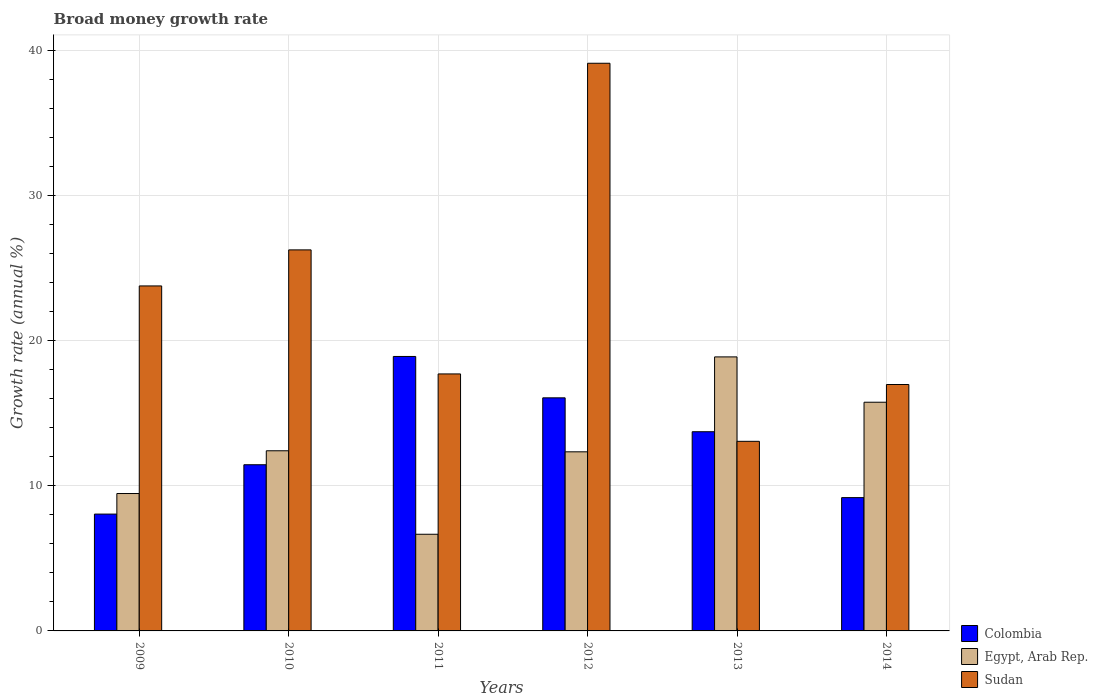How many different coloured bars are there?
Your answer should be very brief. 3. Are the number of bars per tick equal to the number of legend labels?
Make the answer very short. Yes. How many bars are there on the 5th tick from the right?
Ensure brevity in your answer.  3. In how many cases, is the number of bars for a given year not equal to the number of legend labels?
Ensure brevity in your answer.  0. What is the growth rate in Egypt, Arab Rep. in 2010?
Provide a short and direct response. 12.42. Across all years, what is the maximum growth rate in Colombia?
Your answer should be compact. 18.92. Across all years, what is the minimum growth rate in Sudan?
Give a very brief answer. 13.07. What is the total growth rate in Colombia in the graph?
Your answer should be very brief. 77.43. What is the difference between the growth rate in Sudan in 2011 and that in 2012?
Provide a short and direct response. -21.42. What is the difference between the growth rate in Colombia in 2010 and the growth rate in Egypt, Arab Rep. in 2009?
Ensure brevity in your answer.  1.98. What is the average growth rate in Sudan per year?
Keep it short and to the point. 22.83. In the year 2011, what is the difference between the growth rate in Sudan and growth rate in Colombia?
Ensure brevity in your answer.  -1.2. What is the ratio of the growth rate in Sudan in 2009 to that in 2011?
Your answer should be very brief. 1.34. Is the growth rate in Egypt, Arab Rep. in 2010 less than that in 2012?
Keep it short and to the point. No. Is the difference between the growth rate in Sudan in 2010 and 2012 greater than the difference between the growth rate in Colombia in 2010 and 2012?
Keep it short and to the point. No. What is the difference between the highest and the second highest growth rate in Colombia?
Your answer should be compact. 2.85. What is the difference between the highest and the lowest growth rate in Sudan?
Offer a terse response. 26.07. Is the sum of the growth rate in Sudan in 2011 and 2013 greater than the maximum growth rate in Egypt, Arab Rep. across all years?
Provide a short and direct response. Yes. What does the 2nd bar from the left in 2011 represents?
Provide a short and direct response. Egypt, Arab Rep. What does the 2nd bar from the right in 2010 represents?
Make the answer very short. Egypt, Arab Rep. Is it the case that in every year, the sum of the growth rate in Egypt, Arab Rep. and growth rate in Sudan is greater than the growth rate in Colombia?
Offer a very short reply. Yes. What is the difference between two consecutive major ticks on the Y-axis?
Provide a succinct answer. 10. Does the graph contain grids?
Offer a terse response. Yes. How many legend labels are there?
Make the answer very short. 3. What is the title of the graph?
Give a very brief answer. Broad money growth rate. What is the label or title of the X-axis?
Your answer should be compact. Years. What is the label or title of the Y-axis?
Ensure brevity in your answer.  Growth rate (annual %). What is the Growth rate (annual %) of Colombia in 2009?
Your answer should be very brief. 8.06. What is the Growth rate (annual %) of Egypt, Arab Rep. in 2009?
Offer a very short reply. 9.47. What is the Growth rate (annual %) in Sudan in 2009?
Provide a short and direct response. 23.79. What is the Growth rate (annual %) in Colombia in 2010?
Provide a short and direct response. 11.46. What is the Growth rate (annual %) of Egypt, Arab Rep. in 2010?
Make the answer very short. 12.42. What is the Growth rate (annual %) in Sudan in 2010?
Your response must be concise. 26.27. What is the Growth rate (annual %) of Colombia in 2011?
Your answer should be compact. 18.92. What is the Growth rate (annual %) in Egypt, Arab Rep. in 2011?
Provide a succinct answer. 6.66. What is the Growth rate (annual %) of Sudan in 2011?
Keep it short and to the point. 17.72. What is the Growth rate (annual %) of Colombia in 2012?
Provide a short and direct response. 16.07. What is the Growth rate (annual %) of Egypt, Arab Rep. in 2012?
Keep it short and to the point. 12.35. What is the Growth rate (annual %) of Sudan in 2012?
Provide a succinct answer. 39.14. What is the Growth rate (annual %) of Colombia in 2013?
Your answer should be compact. 13.73. What is the Growth rate (annual %) in Egypt, Arab Rep. in 2013?
Ensure brevity in your answer.  18.89. What is the Growth rate (annual %) of Sudan in 2013?
Ensure brevity in your answer.  13.07. What is the Growth rate (annual %) in Colombia in 2014?
Your answer should be very brief. 9.19. What is the Growth rate (annual %) of Egypt, Arab Rep. in 2014?
Your answer should be very brief. 15.77. What is the Growth rate (annual %) of Sudan in 2014?
Provide a short and direct response. 16.99. Across all years, what is the maximum Growth rate (annual %) of Colombia?
Your answer should be compact. 18.92. Across all years, what is the maximum Growth rate (annual %) of Egypt, Arab Rep.?
Make the answer very short. 18.89. Across all years, what is the maximum Growth rate (annual %) of Sudan?
Provide a succinct answer. 39.14. Across all years, what is the minimum Growth rate (annual %) in Colombia?
Your answer should be compact. 8.06. Across all years, what is the minimum Growth rate (annual %) of Egypt, Arab Rep.?
Provide a short and direct response. 6.66. Across all years, what is the minimum Growth rate (annual %) of Sudan?
Offer a terse response. 13.07. What is the total Growth rate (annual %) of Colombia in the graph?
Ensure brevity in your answer.  77.43. What is the total Growth rate (annual %) of Egypt, Arab Rep. in the graph?
Offer a terse response. 75.57. What is the total Growth rate (annual %) in Sudan in the graph?
Your response must be concise. 136.98. What is the difference between the Growth rate (annual %) of Colombia in 2009 and that in 2010?
Your answer should be very brief. -3.4. What is the difference between the Growth rate (annual %) in Egypt, Arab Rep. in 2009 and that in 2010?
Offer a terse response. -2.95. What is the difference between the Growth rate (annual %) of Sudan in 2009 and that in 2010?
Make the answer very short. -2.49. What is the difference between the Growth rate (annual %) in Colombia in 2009 and that in 2011?
Offer a very short reply. -10.87. What is the difference between the Growth rate (annual %) in Egypt, Arab Rep. in 2009 and that in 2011?
Provide a succinct answer. 2.81. What is the difference between the Growth rate (annual %) of Sudan in 2009 and that in 2011?
Offer a terse response. 6.07. What is the difference between the Growth rate (annual %) of Colombia in 2009 and that in 2012?
Offer a very short reply. -8.02. What is the difference between the Growth rate (annual %) in Egypt, Arab Rep. in 2009 and that in 2012?
Keep it short and to the point. -2.87. What is the difference between the Growth rate (annual %) in Sudan in 2009 and that in 2012?
Give a very brief answer. -15.35. What is the difference between the Growth rate (annual %) of Colombia in 2009 and that in 2013?
Give a very brief answer. -5.68. What is the difference between the Growth rate (annual %) in Egypt, Arab Rep. in 2009 and that in 2013?
Your answer should be very brief. -9.42. What is the difference between the Growth rate (annual %) in Sudan in 2009 and that in 2013?
Provide a short and direct response. 10.71. What is the difference between the Growth rate (annual %) in Colombia in 2009 and that in 2014?
Your answer should be compact. -1.14. What is the difference between the Growth rate (annual %) in Egypt, Arab Rep. in 2009 and that in 2014?
Your answer should be very brief. -6.29. What is the difference between the Growth rate (annual %) in Sudan in 2009 and that in 2014?
Provide a short and direct response. 6.8. What is the difference between the Growth rate (annual %) of Colombia in 2010 and that in 2011?
Your answer should be very brief. -7.47. What is the difference between the Growth rate (annual %) in Egypt, Arab Rep. in 2010 and that in 2011?
Give a very brief answer. 5.76. What is the difference between the Growth rate (annual %) in Sudan in 2010 and that in 2011?
Provide a short and direct response. 8.55. What is the difference between the Growth rate (annual %) in Colombia in 2010 and that in 2012?
Give a very brief answer. -4.61. What is the difference between the Growth rate (annual %) in Egypt, Arab Rep. in 2010 and that in 2012?
Provide a short and direct response. 0.07. What is the difference between the Growth rate (annual %) in Sudan in 2010 and that in 2012?
Give a very brief answer. -12.87. What is the difference between the Growth rate (annual %) of Colombia in 2010 and that in 2013?
Offer a terse response. -2.28. What is the difference between the Growth rate (annual %) of Egypt, Arab Rep. in 2010 and that in 2013?
Offer a terse response. -6.47. What is the difference between the Growth rate (annual %) in Sudan in 2010 and that in 2013?
Offer a terse response. 13.2. What is the difference between the Growth rate (annual %) in Colombia in 2010 and that in 2014?
Your answer should be very brief. 2.27. What is the difference between the Growth rate (annual %) of Egypt, Arab Rep. in 2010 and that in 2014?
Make the answer very short. -3.35. What is the difference between the Growth rate (annual %) in Sudan in 2010 and that in 2014?
Offer a very short reply. 9.28. What is the difference between the Growth rate (annual %) in Colombia in 2011 and that in 2012?
Keep it short and to the point. 2.85. What is the difference between the Growth rate (annual %) in Egypt, Arab Rep. in 2011 and that in 2012?
Your answer should be compact. -5.68. What is the difference between the Growth rate (annual %) in Sudan in 2011 and that in 2012?
Provide a short and direct response. -21.42. What is the difference between the Growth rate (annual %) of Colombia in 2011 and that in 2013?
Provide a succinct answer. 5.19. What is the difference between the Growth rate (annual %) in Egypt, Arab Rep. in 2011 and that in 2013?
Provide a succinct answer. -12.23. What is the difference between the Growth rate (annual %) in Sudan in 2011 and that in 2013?
Keep it short and to the point. 4.65. What is the difference between the Growth rate (annual %) in Colombia in 2011 and that in 2014?
Offer a terse response. 9.73. What is the difference between the Growth rate (annual %) in Egypt, Arab Rep. in 2011 and that in 2014?
Keep it short and to the point. -9.1. What is the difference between the Growth rate (annual %) of Sudan in 2011 and that in 2014?
Provide a succinct answer. 0.73. What is the difference between the Growth rate (annual %) of Colombia in 2012 and that in 2013?
Ensure brevity in your answer.  2.34. What is the difference between the Growth rate (annual %) of Egypt, Arab Rep. in 2012 and that in 2013?
Your response must be concise. -6.55. What is the difference between the Growth rate (annual %) of Sudan in 2012 and that in 2013?
Ensure brevity in your answer.  26.07. What is the difference between the Growth rate (annual %) of Colombia in 2012 and that in 2014?
Offer a terse response. 6.88. What is the difference between the Growth rate (annual %) in Egypt, Arab Rep. in 2012 and that in 2014?
Ensure brevity in your answer.  -3.42. What is the difference between the Growth rate (annual %) in Sudan in 2012 and that in 2014?
Your answer should be compact. 22.15. What is the difference between the Growth rate (annual %) of Colombia in 2013 and that in 2014?
Give a very brief answer. 4.54. What is the difference between the Growth rate (annual %) in Egypt, Arab Rep. in 2013 and that in 2014?
Offer a very short reply. 3.13. What is the difference between the Growth rate (annual %) of Sudan in 2013 and that in 2014?
Provide a short and direct response. -3.92. What is the difference between the Growth rate (annual %) of Colombia in 2009 and the Growth rate (annual %) of Egypt, Arab Rep. in 2010?
Keep it short and to the point. -4.36. What is the difference between the Growth rate (annual %) of Colombia in 2009 and the Growth rate (annual %) of Sudan in 2010?
Give a very brief answer. -18.22. What is the difference between the Growth rate (annual %) in Egypt, Arab Rep. in 2009 and the Growth rate (annual %) in Sudan in 2010?
Provide a succinct answer. -16.8. What is the difference between the Growth rate (annual %) in Colombia in 2009 and the Growth rate (annual %) in Egypt, Arab Rep. in 2011?
Your answer should be compact. 1.39. What is the difference between the Growth rate (annual %) in Colombia in 2009 and the Growth rate (annual %) in Sudan in 2011?
Your answer should be very brief. -9.66. What is the difference between the Growth rate (annual %) in Egypt, Arab Rep. in 2009 and the Growth rate (annual %) in Sudan in 2011?
Your response must be concise. -8.25. What is the difference between the Growth rate (annual %) in Colombia in 2009 and the Growth rate (annual %) in Egypt, Arab Rep. in 2012?
Ensure brevity in your answer.  -4.29. What is the difference between the Growth rate (annual %) in Colombia in 2009 and the Growth rate (annual %) in Sudan in 2012?
Your answer should be very brief. -31.08. What is the difference between the Growth rate (annual %) in Egypt, Arab Rep. in 2009 and the Growth rate (annual %) in Sudan in 2012?
Your answer should be very brief. -29.67. What is the difference between the Growth rate (annual %) in Colombia in 2009 and the Growth rate (annual %) in Egypt, Arab Rep. in 2013?
Offer a terse response. -10.84. What is the difference between the Growth rate (annual %) of Colombia in 2009 and the Growth rate (annual %) of Sudan in 2013?
Offer a terse response. -5.02. What is the difference between the Growth rate (annual %) of Egypt, Arab Rep. in 2009 and the Growth rate (annual %) of Sudan in 2013?
Ensure brevity in your answer.  -3.6. What is the difference between the Growth rate (annual %) of Colombia in 2009 and the Growth rate (annual %) of Egypt, Arab Rep. in 2014?
Provide a short and direct response. -7.71. What is the difference between the Growth rate (annual %) of Colombia in 2009 and the Growth rate (annual %) of Sudan in 2014?
Make the answer very short. -8.93. What is the difference between the Growth rate (annual %) in Egypt, Arab Rep. in 2009 and the Growth rate (annual %) in Sudan in 2014?
Offer a very short reply. -7.52. What is the difference between the Growth rate (annual %) of Colombia in 2010 and the Growth rate (annual %) of Egypt, Arab Rep. in 2011?
Make the answer very short. 4.79. What is the difference between the Growth rate (annual %) of Colombia in 2010 and the Growth rate (annual %) of Sudan in 2011?
Your answer should be very brief. -6.26. What is the difference between the Growth rate (annual %) in Egypt, Arab Rep. in 2010 and the Growth rate (annual %) in Sudan in 2011?
Your response must be concise. -5.3. What is the difference between the Growth rate (annual %) in Colombia in 2010 and the Growth rate (annual %) in Egypt, Arab Rep. in 2012?
Your response must be concise. -0.89. What is the difference between the Growth rate (annual %) of Colombia in 2010 and the Growth rate (annual %) of Sudan in 2012?
Your answer should be compact. -27.68. What is the difference between the Growth rate (annual %) of Egypt, Arab Rep. in 2010 and the Growth rate (annual %) of Sudan in 2012?
Your answer should be compact. -26.72. What is the difference between the Growth rate (annual %) in Colombia in 2010 and the Growth rate (annual %) in Egypt, Arab Rep. in 2013?
Offer a terse response. -7.44. What is the difference between the Growth rate (annual %) in Colombia in 2010 and the Growth rate (annual %) in Sudan in 2013?
Make the answer very short. -1.62. What is the difference between the Growth rate (annual %) of Egypt, Arab Rep. in 2010 and the Growth rate (annual %) of Sudan in 2013?
Your answer should be compact. -0.65. What is the difference between the Growth rate (annual %) of Colombia in 2010 and the Growth rate (annual %) of Egypt, Arab Rep. in 2014?
Make the answer very short. -4.31. What is the difference between the Growth rate (annual %) in Colombia in 2010 and the Growth rate (annual %) in Sudan in 2014?
Your response must be concise. -5.53. What is the difference between the Growth rate (annual %) in Egypt, Arab Rep. in 2010 and the Growth rate (annual %) in Sudan in 2014?
Provide a succinct answer. -4.57. What is the difference between the Growth rate (annual %) of Colombia in 2011 and the Growth rate (annual %) of Egypt, Arab Rep. in 2012?
Your answer should be compact. 6.57. What is the difference between the Growth rate (annual %) in Colombia in 2011 and the Growth rate (annual %) in Sudan in 2012?
Give a very brief answer. -20.22. What is the difference between the Growth rate (annual %) in Egypt, Arab Rep. in 2011 and the Growth rate (annual %) in Sudan in 2012?
Make the answer very short. -32.48. What is the difference between the Growth rate (annual %) of Colombia in 2011 and the Growth rate (annual %) of Egypt, Arab Rep. in 2013?
Make the answer very short. 0.03. What is the difference between the Growth rate (annual %) in Colombia in 2011 and the Growth rate (annual %) in Sudan in 2013?
Ensure brevity in your answer.  5.85. What is the difference between the Growth rate (annual %) of Egypt, Arab Rep. in 2011 and the Growth rate (annual %) of Sudan in 2013?
Keep it short and to the point. -6.41. What is the difference between the Growth rate (annual %) of Colombia in 2011 and the Growth rate (annual %) of Egypt, Arab Rep. in 2014?
Your answer should be compact. 3.16. What is the difference between the Growth rate (annual %) of Colombia in 2011 and the Growth rate (annual %) of Sudan in 2014?
Your answer should be very brief. 1.93. What is the difference between the Growth rate (annual %) of Egypt, Arab Rep. in 2011 and the Growth rate (annual %) of Sudan in 2014?
Your answer should be compact. -10.33. What is the difference between the Growth rate (annual %) in Colombia in 2012 and the Growth rate (annual %) in Egypt, Arab Rep. in 2013?
Your answer should be compact. -2.82. What is the difference between the Growth rate (annual %) in Colombia in 2012 and the Growth rate (annual %) in Sudan in 2013?
Give a very brief answer. 3. What is the difference between the Growth rate (annual %) in Egypt, Arab Rep. in 2012 and the Growth rate (annual %) in Sudan in 2013?
Ensure brevity in your answer.  -0.72. What is the difference between the Growth rate (annual %) of Colombia in 2012 and the Growth rate (annual %) of Egypt, Arab Rep. in 2014?
Provide a succinct answer. 0.3. What is the difference between the Growth rate (annual %) of Colombia in 2012 and the Growth rate (annual %) of Sudan in 2014?
Ensure brevity in your answer.  -0.92. What is the difference between the Growth rate (annual %) of Egypt, Arab Rep. in 2012 and the Growth rate (annual %) of Sudan in 2014?
Offer a very short reply. -4.64. What is the difference between the Growth rate (annual %) of Colombia in 2013 and the Growth rate (annual %) of Egypt, Arab Rep. in 2014?
Offer a terse response. -2.03. What is the difference between the Growth rate (annual %) of Colombia in 2013 and the Growth rate (annual %) of Sudan in 2014?
Ensure brevity in your answer.  -3.26. What is the difference between the Growth rate (annual %) in Egypt, Arab Rep. in 2013 and the Growth rate (annual %) in Sudan in 2014?
Your answer should be compact. 1.9. What is the average Growth rate (annual %) in Colombia per year?
Make the answer very short. 12.91. What is the average Growth rate (annual %) in Egypt, Arab Rep. per year?
Give a very brief answer. 12.6. What is the average Growth rate (annual %) in Sudan per year?
Provide a succinct answer. 22.83. In the year 2009, what is the difference between the Growth rate (annual %) in Colombia and Growth rate (annual %) in Egypt, Arab Rep.?
Offer a very short reply. -1.42. In the year 2009, what is the difference between the Growth rate (annual %) of Colombia and Growth rate (annual %) of Sudan?
Your answer should be very brief. -15.73. In the year 2009, what is the difference between the Growth rate (annual %) in Egypt, Arab Rep. and Growth rate (annual %) in Sudan?
Ensure brevity in your answer.  -14.31. In the year 2010, what is the difference between the Growth rate (annual %) of Colombia and Growth rate (annual %) of Egypt, Arab Rep.?
Provide a short and direct response. -0.96. In the year 2010, what is the difference between the Growth rate (annual %) of Colombia and Growth rate (annual %) of Sudan?
Make the answer very short. -14.81. In the year 2010, what is the difference between the Growth rate (annual %) of Egypt, Arab Rep. and Growth rate (annual %) of Sudan?
Provide a short and direct response. -13.85. In the year 2011, what is the difference between the Growth rate (annual %) in Colombia and Growth rate (annual %) in Egypt, Arab Rep.?
Give a very brief answer. 12.26. In the year 2011, what is the difference between the Growth rate (annual %) of Colombia and Growth rate (annual %) of Sudan?
Offer a very short reply. 1.2. In the year 2011, what is the difference between the Growth rate (annual %) of Egypt, Arab Rep. and Growth rate (annual %) of Sudan?
Give a very brief answer. -11.06. In the year 2012, what is the difference between the Growth rate (annual %) in Colombia and Growth rate (annual %) in Egypt, Arab Rep.?
Your answer should be very brief. 3.72. In the year 2012, what is the difference between the Growth rate (annual %) of Colombia and Growth rate (annual %) of Sudan?
Make the answer very short. -23.07. In the year 2012, what is the difference between the Growth rate (annual %) in Egypt, Arab Rep. and Growth rate (annual %) in Sudan?
Ensure brevity in your answer.  -26.79. In the year 2013, what is the difference between the Growth rate (annual %) of Colombia and Growth rate (annual %) of Egypt, Arab Rep.?
Your answer should be very brief. -5.16. In the year 2013, what is the difference between the Growth rate (annual %) of Colombia and Growth rate (annual %) of Sudan?
Your answer should be very brief. 0.66. In the year 2013, what is the difference between the Growth rate (annual %) in Egypt, Arab Rep. and Growth rate (annual %) in Sudan?
Make the answer very short. 5.82. In the year 2014, what is the difference between the Growth rate (annual %) in Colombia and Growth rate (annual %) in Egypt, Arab Rep.?
Your response must be concise. -6.58. In the year 2014, what is the difference between the Growth rate (annual %) of Colombia and Growth rate (annual %) of Sudan?
Provide a succinct answer. -7.8. In the year 2014, what is the difference between the Growth rate (annual %) in Egypt, Arab Rep. and Growth rate (annual %) in Sudan?
Make the answer very short. -1.22. What is the ratio of the Growth rate (annual %) in Colombia in 2009 to that in 2010?
Offer a terse response. 0.7. What is the ratio of the Growth rate (annual %) of Egypt, Arab Rep. in 2009 to that in 2010?
Offer a very short reply. 0.76. What is the ratio of the Growth rate (annual %) of Sudan in 2009 to that in 2010?
Offer a terse response. 0.91. What is the ratio of the Growth rate (annual %) of Colombia in 2009 to that in 2011?
Provide a short and direct response. 0.43. What is the ratio of the Growth rate (annual %) of Egypt, Arab Rep. in 2009 to that in 2011?
Your response must be concise. 1.42. What is the ratio of the Growth rate (annual %) of Sudan in 2009 to that in 2011?
Provide a short and direct response. 1.34. What is the ratio of the Growth rate (annual %) in Colombia in 2009 to that in 2012?
Keep it short and to the point. 0.5. What is the ratio of the Growth rate (annual %) in Egypt, Arab Rep. in 2009 to that in 2012?
Offer a terse response. 0.77. What is the ratio of the Growth rate (annual %) in Sudan in 2009 to that in 2012?
Provide a succinct answer. 0.61. What is the ratio of the Growth rate (annual %) in Colombia in 2009 to that in 2013?
Offer a very short reply. 0.59. What is the ratio of the Growth rate (annual %) in Egypt, Arab Rep. in 2009 to that in 2013?
Provide a short and direct response. 0.5. What is the ratio of the Growth rate (annual %) of Sudan in 2009 to that in 2013?
Offer a terse response. 1.82. What is the ratio of the Growth rate (annual %) of Colombia in 2009 to that in 2014?
Give a very brief answer. 0.88. What is the ratio of the Growth rate (annual %) in Egypt, Arab Rep. in 2009 to that in 2014?
Your answer should be very brief. 0.6. What is the ratio of the Growth rate (annual %) of Sudan in 2009 to that in 2014?
Provide a short and direct response. 1.4. What is the ratio of the Growth rate (annual %) in Colombia in 2010 to that in 2011?
Provide a short and direct response. 0.61. What is the ratio of the Growth rate (annual %) of Egypt, Arab Rep. in 2010 to that in 2011?
Your answer should be compact. 1.86. What is the ratio of the Growth rate (annual %) in Sudan in 2010 to that in 2011?
Provide a short and direct response. 1.48. What is the ratio of the Growth rate (annual %) in Colombia in 2010 to that in 2012?
Ensure brevity in your answer.  0.71. What is the ratio of the Growth rate (annual %) of Egypt, Arab Rep. in 2010 to that in 2012?
Your answer should be very brief. 1.01. What is the ratio of the Growth rate (annual %) in Sudan in 2010 to that in 2012?
Provide a succinct answer. 0.67. What is the ratio of the Growth rate (annual %) of Colombia in 2010 to that in 2013?
Your response must be concise. 0.83. What is the ratio of the Growth rate (annual %) in Egypt, Arab Rep. in 2010 to that in 2013?
Offer a very short reply. 0.66. What is the ratio of the Growth rate (annual %) in Sudan in 2010 to that in 2013?
Keep it short and to the point. 2.01. What is the ratio of the Growth rate (annual %) of Colombia in 2010 to that in 2014?
Keep it short and to the point. 1.25. What is the ratio of the Growth rate (annual %) in Egypt, Arab Rep. in 2010 to that in 2014?
Give a very brief answer. 0.79. What is the ratio of the Growth rate (annual %) of Sudan in 2010 to that in 2014?
Make the answer very short. 1.55. What is the ratio of the Growth rate (annual %) in Colombia in 2011 to that in 2012?
Your response must be concise. 1.18. What is the ratio of the Growth rate (annual %) in Egypt, Arab Rep. in 2011 to that in 2012?
Your answer should be very brief. 0.54. What is the ratio of the Growth rate (annual %) in Sudan in 2011 to that in 2012?
Your answer should be very brief. 0.45. What is the ratio of the Growth rate (annual %) in Colombia in 2011 to that in 2013?
Keep it short and to the point. 1.38. What is the ratio of the Growth rate (annual %) in Egypt, Arab Rep. in 2011 to that in 2013?
Offer a terse response. 0.35. What is the ratio of the Growth rate (annual %) of Sudan in 2011 to that in 2013?
Offer a very short reply. 1.36. What is the ratio of the Growth rate (annual %) in Colombia in 2011 to that in 2014?
Provide a succinct answer. 2.06. What is the ratio of the Growth rate (annual %) of Egypt, Arab Rep. in 2011 to that in 2014?
Your answer should be very brief. 0.42. What is the ratio of the Growth rate (annual %) in Sudan in 2011 to that in 2014?
Ensure brevity in your answer.  1.04. What is the ratio of the Growth rate (annual %) of Colombia in 2012 to that in 2013?
Keep it short and to the point. 1.17. What is the ratio of the Growth rate (annual %) in Egypt, Arab Rep. in 2012 to that in 2013?
Make the answer very short. 0.65. What is the ratio of the Growth rate (annual %) of Sudan in 2012 to that in 2013?
Your response must be concise. 2.99. What is the ratio of the Growth rate (annual %) in Colombia in 2012 to that in 2014?
Make the answer very short. 1.75. What is the ratio of the Growth rate (annual %) of Egypt, Arab Rep. in 2012 to that in 2014?
Your response must be concise. 0.78. What is the ratio of the Growth rate (annual %) of Sudan in 2012 to that in 2014?
Provide a short and direct response. 2.3. What is the ratio of the Growth rate (annual %) of Colombia in 2013 to that in 2014?
Your answer should be very brief. 1.49. What is the ratio of the Growth rate (annual %) in Egypt, Arab Rep. in 2013 to that in 2014?
Provide a short and direct response. 1.2. What is the ratio of the Growth rate (annual %) of Sudan in 2013 to that in 2014?
Make the answer very short. 0.77. What is the difference between the highest and the second highest Growth rate (annual %) of Colombia?
Keep it short and to the point. 2.85. What is the difference between the highest and the second highest Growth rate (annual %) of Egypt, Arab Rep.?
Ensure brevity in your answer.  3.13. What is the difference between the highest and the second highest Growth rate (annual %) in Sudan?
Provide a short and direct response. 12.87. What is the difference between the highest and the lowest Growth rate (annual %) in Colombia?
Offer a terse response. 10.87. What is the difference between the highest and the lowest Growth rate (annual %) in Egypt, Arab Rep.?
Provide a succinct answer. 12.23. What is the difference between the highest and the lowest Growth rate (annual %) in Sudan?
Ensure brevity in your answer.  26.07. 